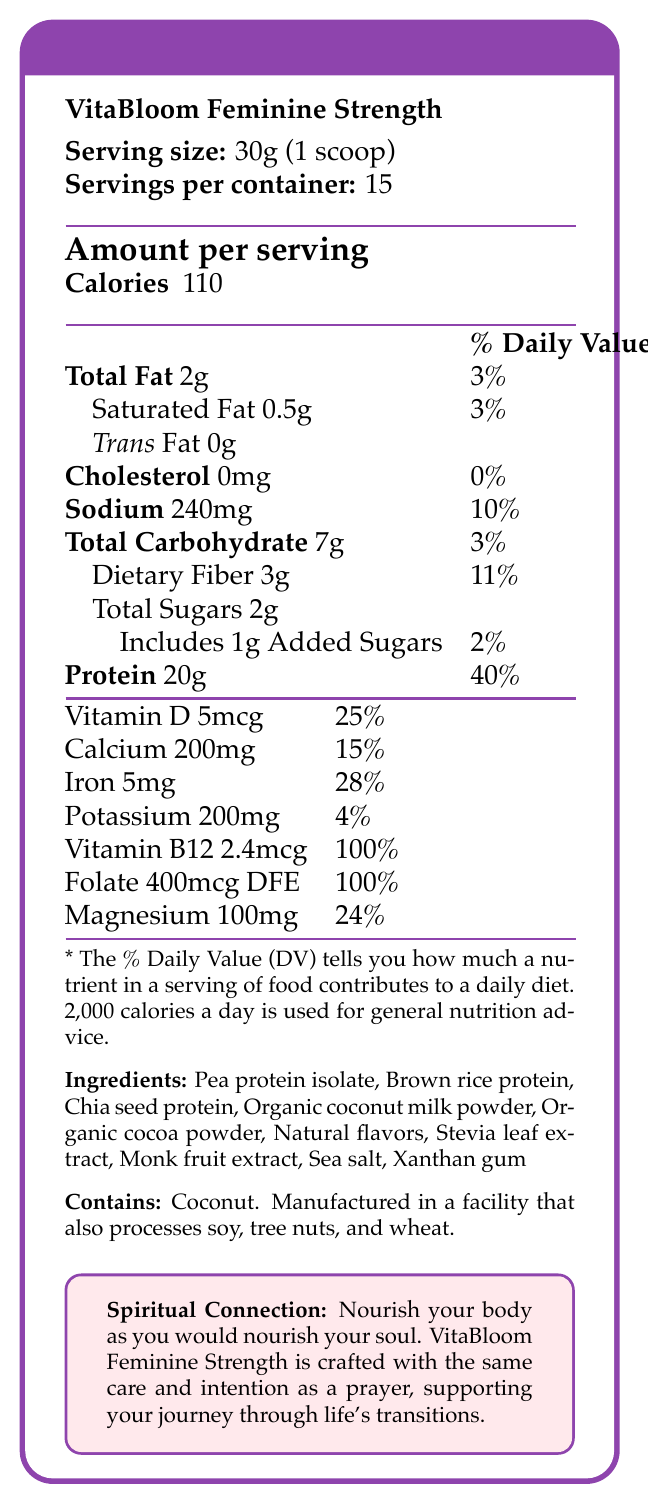what is the serving size? The serving size is stated directly at the top under the product name as "30g (1 scoop)".
Answer: 30g (1 scoop) how many servings are in each container? The document indicates "Servings per container: 15."
Answer: 15 how many grams of dietary fiber does each serving contain? The total dietary fiber per serving is listed as "Dietary Fiber 3g" in the nutrition facts.
Answer: 3g what is the amount of protein per serving? The amount of protein per serving is listed as "Protein 20g" with a daily value percentage of 40%.
Answer: 20g how much sodium does one serving have? The sodium content per serving is specified as "Sodium 240mg" with a daily value percentage of 10%.
Answer: 240mg What percentage of the daily value of iron does one serving provide? A. 15% B. 25% C. 28% D. 40% E. 100% The document lists the daily value percentage for iron as "Iron 5mg & 28%".
Answer: C. 28% How much Vitamin B12 does one serving of the product provide in micrograms? A. 2.4mcg B. 5mcg C. 100mcg D. 15mcg The amount of Vitamin B12 is listed as "Vitamin B12 2.4mcg & 100%".
Answer: A. 2.4mcg does this product contain any cholesterol? The document indicates that the product contains "Cholesterol 0mg & 0%," which means it contains no cholesterol.
Answer: No summarize the main idea of the document. The document provides comprehensive nutritional facts and emphasizes the product's suitability for women over 40, including its health benefits and spiritual connection.
Answer: The document details the nutritional information for VitaBloom Feminine Strength, a plant-based protein powder formulated for women over 40. It provides specifics on serving size, calories, macros (fats, carbs, protein), vitamins, and minerals. It highlights the product's ingredients and allergen information, alongside its health and spiritual benefits aimed at women undergoing perimenopause and menopause. How much potassium does one serving provide? The document indicates "Potassium 200mg & 4%" for the potassium content per serving.
Answer: 200mg Which vitamins are provided at 100% of the daily value per serving? The document lists Folate as "400mcg DFE & 100%" and Vitamin B12 as "2.4mcg & 100%."
Answer: Folate and Vitamin B12 what is the main purpose of this product? The marketing claims highlight these benefits, stating support for bone health, muscle maintenance, and hormonal balance.
Answer: To support bone health, muscle maintenance, and hormonal balance during perimenopause and menopause in women over 40. is the product free from artificial sweeteners and preservatives? One of the marketing claims is "No artificial sweeteners or preservatives."
Answer: Yes what are the main protein sources in VitaBloom Feminine Strength? These are the first ingredients listed in the ingredients section.
Answer: Pea protein isolate, Brown rice protein, Chia seed protein is this product suitable for someone with a coconut allergy? The allergen information states "Contains coconut," which makes it unsuitable for someone with a coconut allergy.
Answer: No can this product’s nutrient values be completely determined based on the document? While most nutrients are given, some specific values, such as certain trace minerals and amino acid profiles, are not included and cannot be determined from the document alone.
Answer: No Based on the document, how many grams of added sugars are there per serving? A. 2g B. 1g C. 0g D. 3g The document states "Includes 1g Added Sugars & 2%."
Answer: B. 1g what are some benefits of this protein powder according to the document? The marketing claims section lists these benefits eindeutig.
Answer: Supports bone health, muscle maintenance, and hormonal balance during perimenopause and menopause; rich in plant-based omega-3 fatty acids; contains no artificial sweeteners or preservatives 